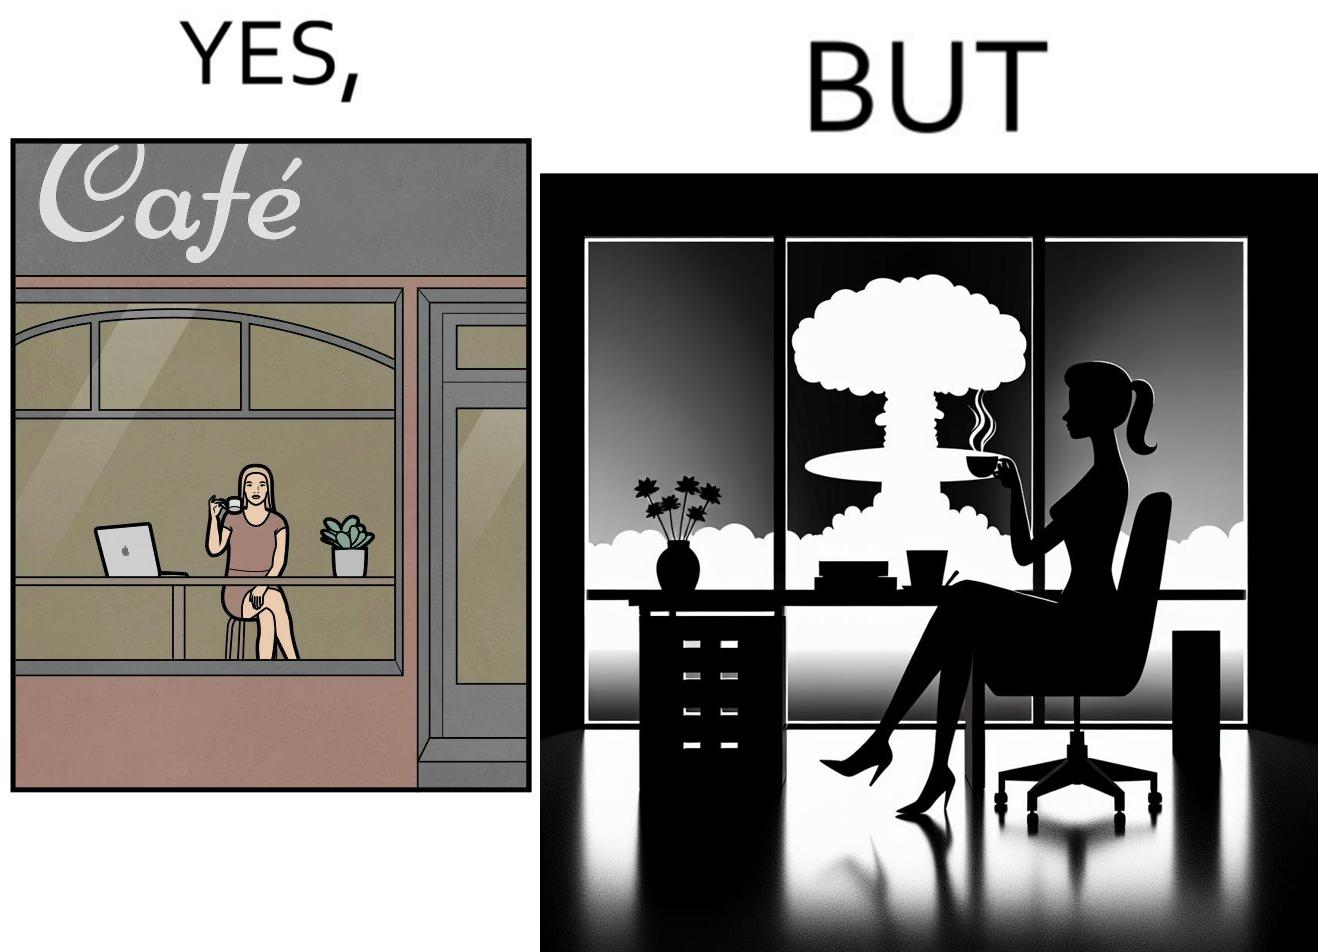Why is this image considered satirical? The images are funny since it shows a woman simply sipping from a cup at ease in a cafe with her laptop not caring about anything going on outside the cafe even though the situation is very grave,that is, a nuclear blast 